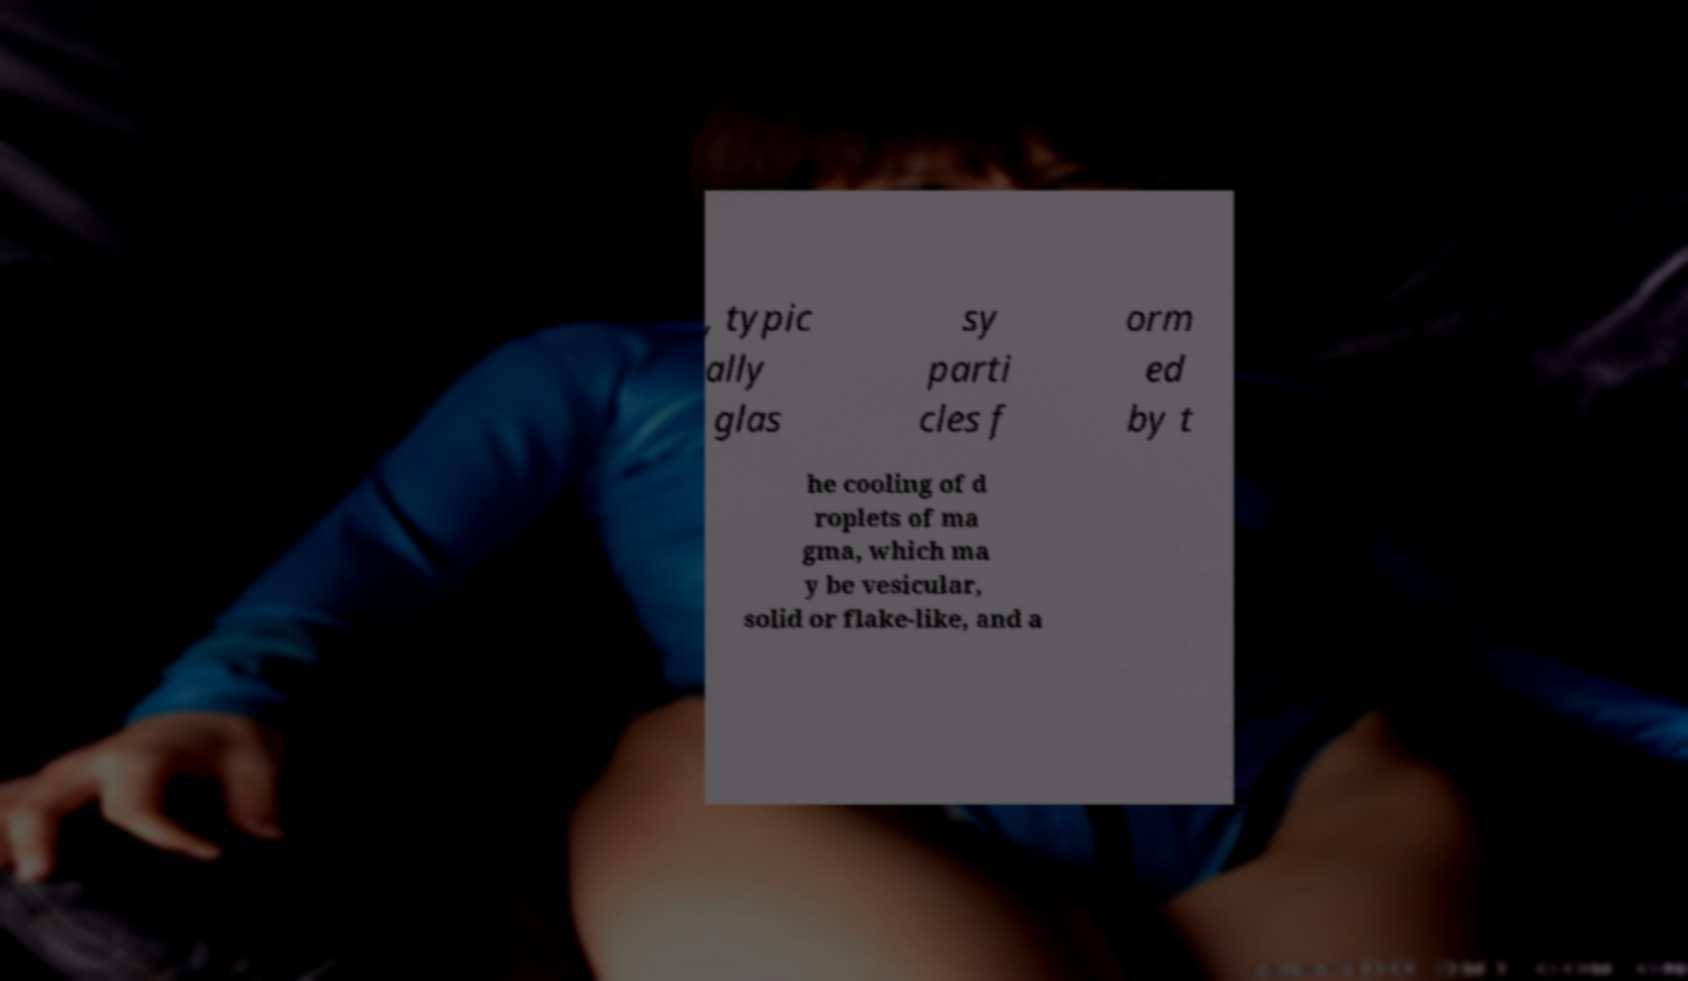There's text embedded in this image that I need extracted. Can you transcribe it verbatim? , typic ally glas sy parti cles f orm ed by t he cooling of d roplets of ma gma, which ma y be vesicular, solid or flake-like, and a 